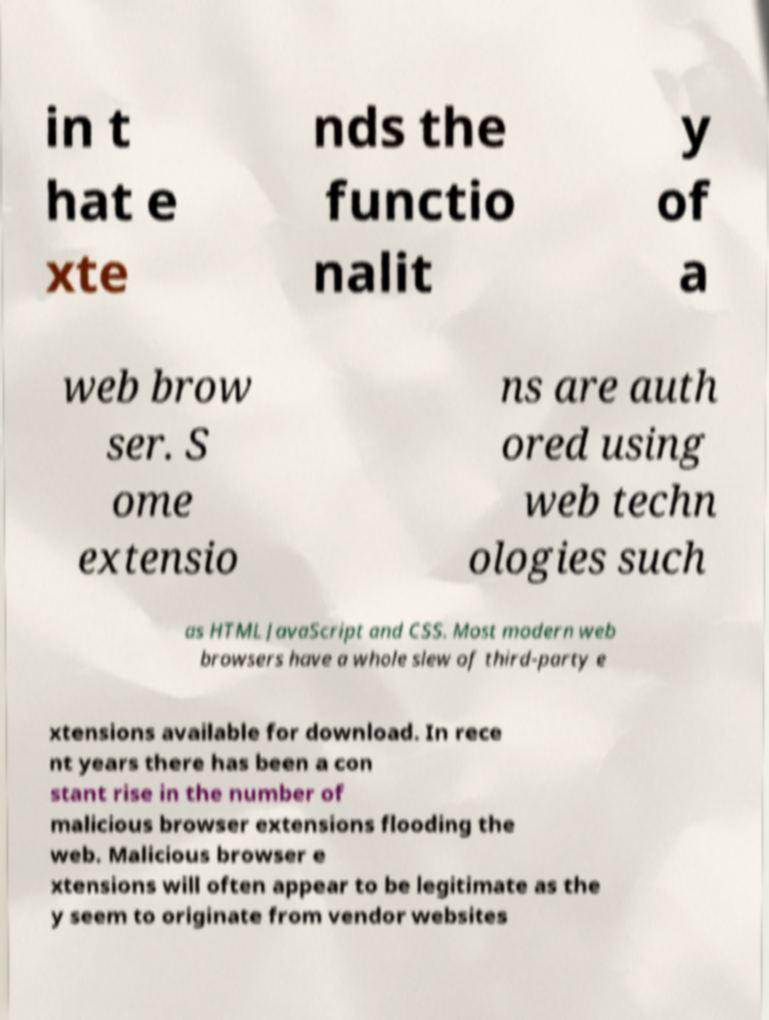I need the written content from this picture converted into text. Can you do that? in t hat e xte nds the functio nalit y of a web brow ser. S ome extensio ns are auth ored using web techn ologies such as HTML JavaScript and CSS. Most modern web browsers have a whole slew of third-party e xtensions available for download. In rece nt years there has been a con stant rise in the number of malicious browser extensions flooding the web. Malicious browser e xtensions will often appear to be legitimate as the y seem to originate from vendor websites 